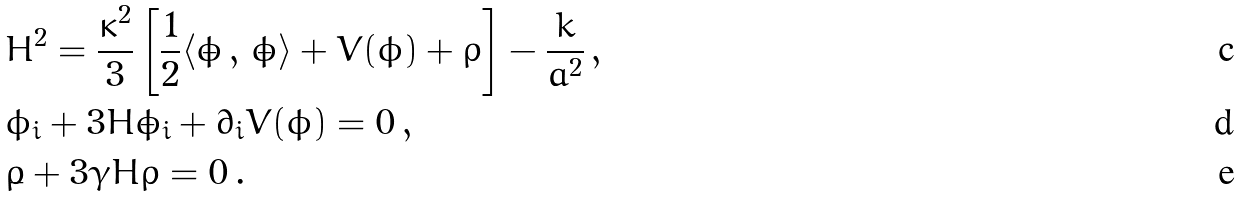<formula> <loc_0><loc_0><loc_500><loc_500>& H ^ { 2 } = \frac { \kappa ^ { 2 } } { 3 } \left [ \frac { 1 } { 2 } \langle \dot { \phi } \, , \, \dot { \phi } \rangle + V ( \phi ) + \rho \right ] - \frac { k } { a ^ { 2 } } \, , \\ & \ddot { \phi } _ { i } + 3 H \dot { \phi } _ { i } + \partial _ { i } V ( \phi ) = 0 \, , \\ & \dot { \rho } + 3 \gamma H \rho = 0 \, .</formula> 